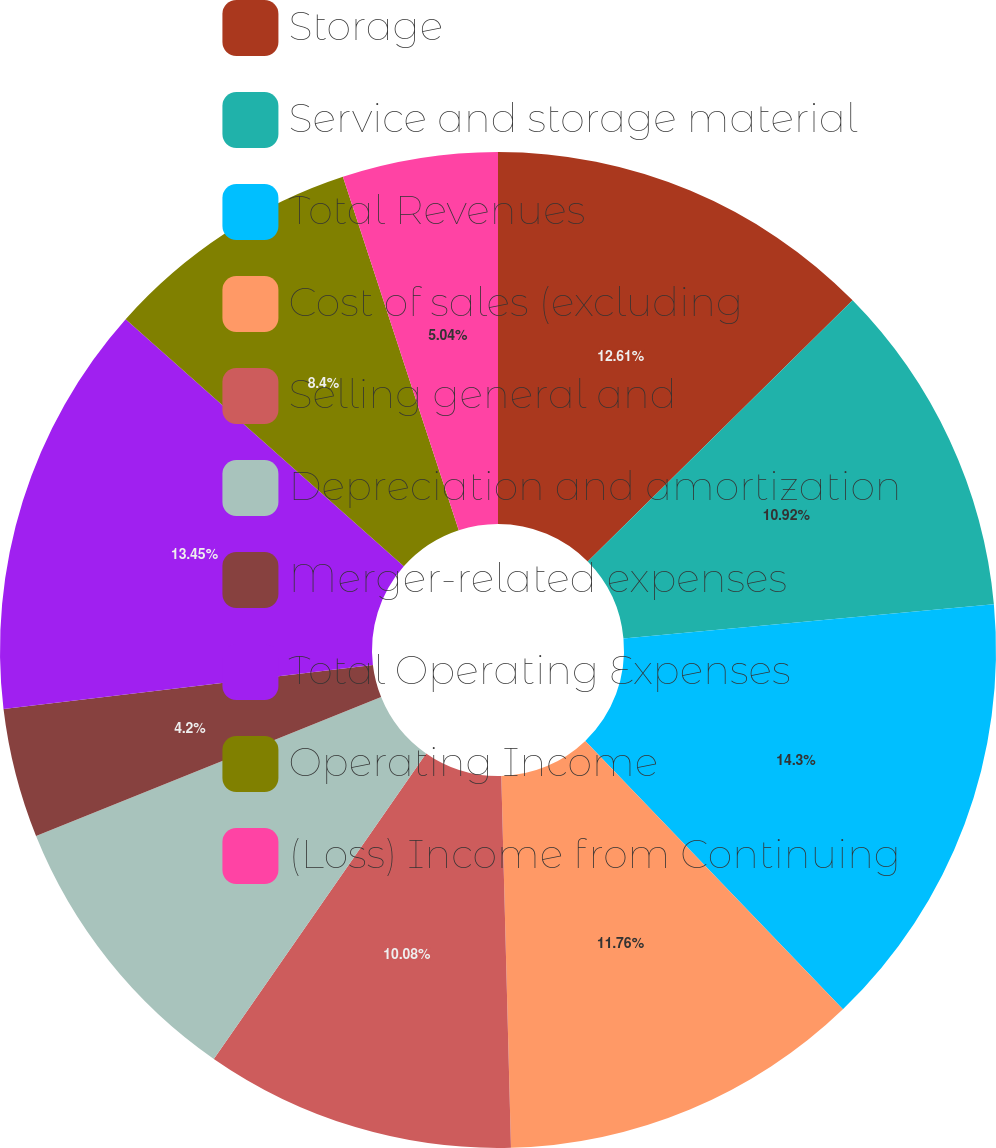Convert chart. <chart><loc_0><loc_0><loc_500><loc_500><pie_chart><fcel>Storage<fcel>Service and storage material<fcel>Total Revenues<fcel>Cost of sales (excluding<fcel>Selling general and<fcel>Depreciation and amortization<fcel>Merger-related expenses<fcel>Total Operating Expenses<fcel>Operating Income<fcel>(Loss) Income from Continuing<nl><fcel>12.61%<fcel>10.92%<fcel>14.29%<fcel>11.76%<fcel>10.08%<fcel>9.24%<fcel>4.2%<fcel>13.45%<fcel>8.4%<fcel>5.04%<nl></chart> 